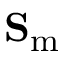<formula> <loc_0><loc_0><loc_500><loc_500>S _ { m }</formula> 